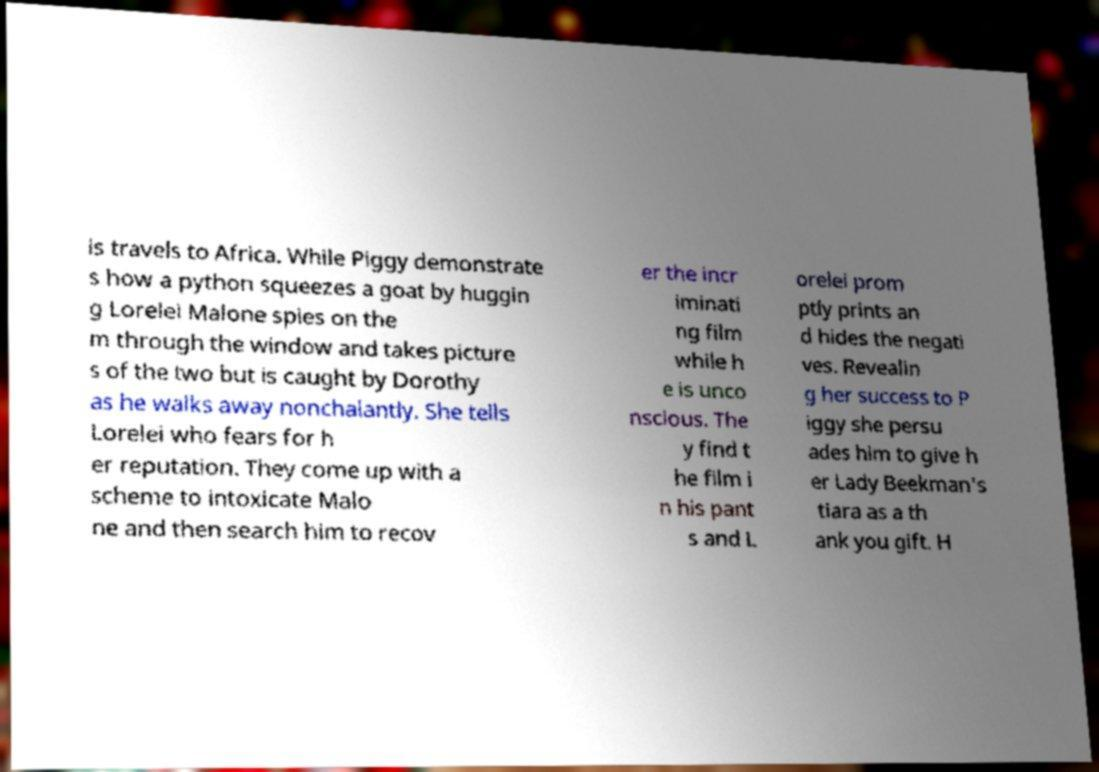Please identify and transcribe the text found in this image. is travels to Africa. While Piggy demonstrate s how a python squeezes a goat by huggin g Lorelei Malone spies on the m through the window and takes picture s of the two but is caught by Dorothy as he walks away nonchalantly. She tells Lorelei who fears for h er reputation. They come up with a scheme to intoxicate Malo ne and then search him to recov er the incr iminati ng film while h e is unco nscious. The y find t he film i n his pant s and L orelei prom ptly prints an d hides the negati ves. Revealin g her success to P iggy she persu ades him to give h er Lady Beekman's tiara as a th ank you gift. H 